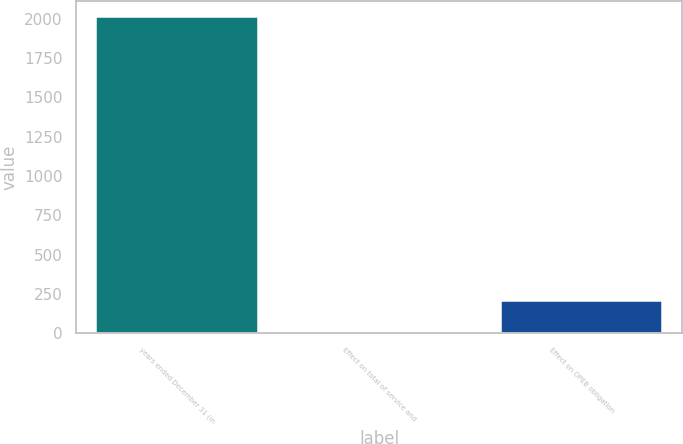Convert chart to OTSL. <chart><loc_0><loc_0><loc_500><loc_500><bar_chart><fcel>years ended December 31 (in<fcel>Effect on total of service and<fcel>Effect on OPEB obligation<nl><fcel>2011<fcel>4<fcel>204.7<nl></chart> 